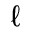<formula> <loc_0><loc_0><loc_500><loc_500>\ell</formula> 